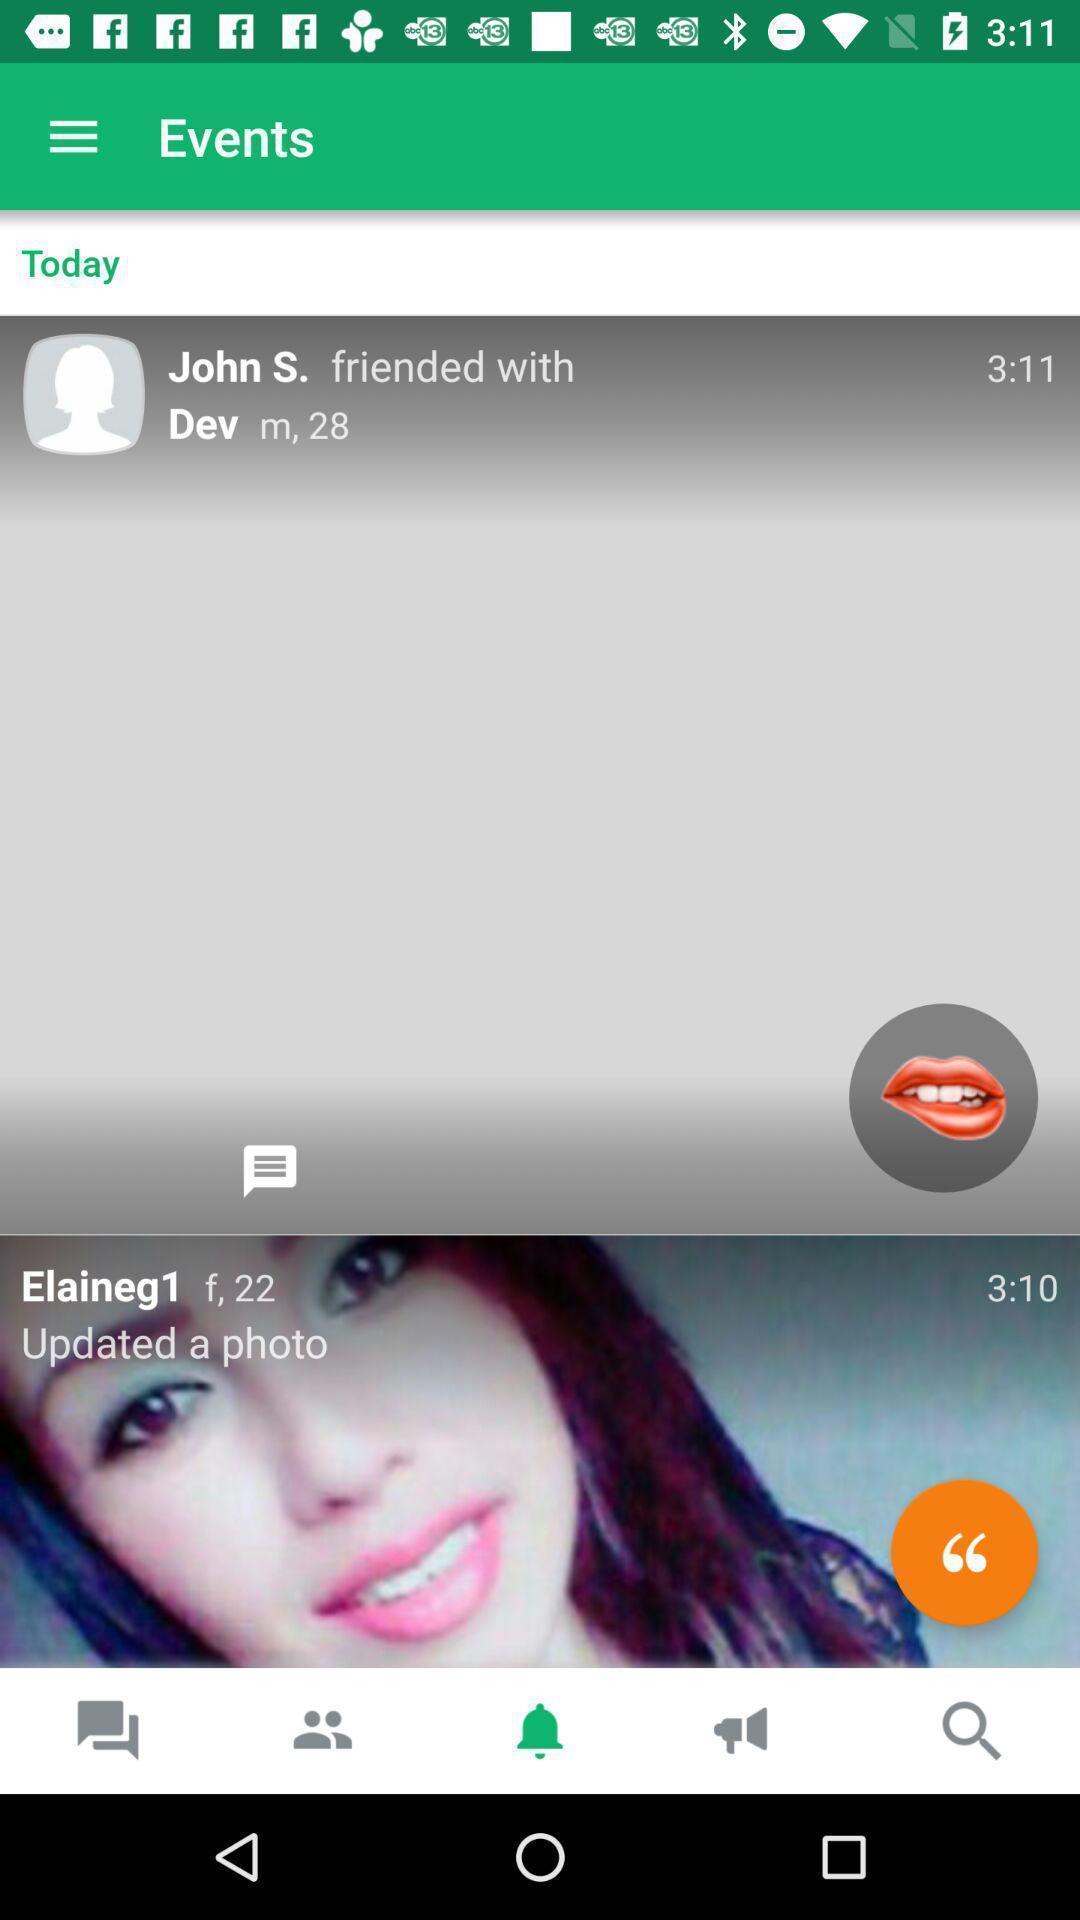Tell me about the visual elements in this screen capture. Page shows about updated events. 